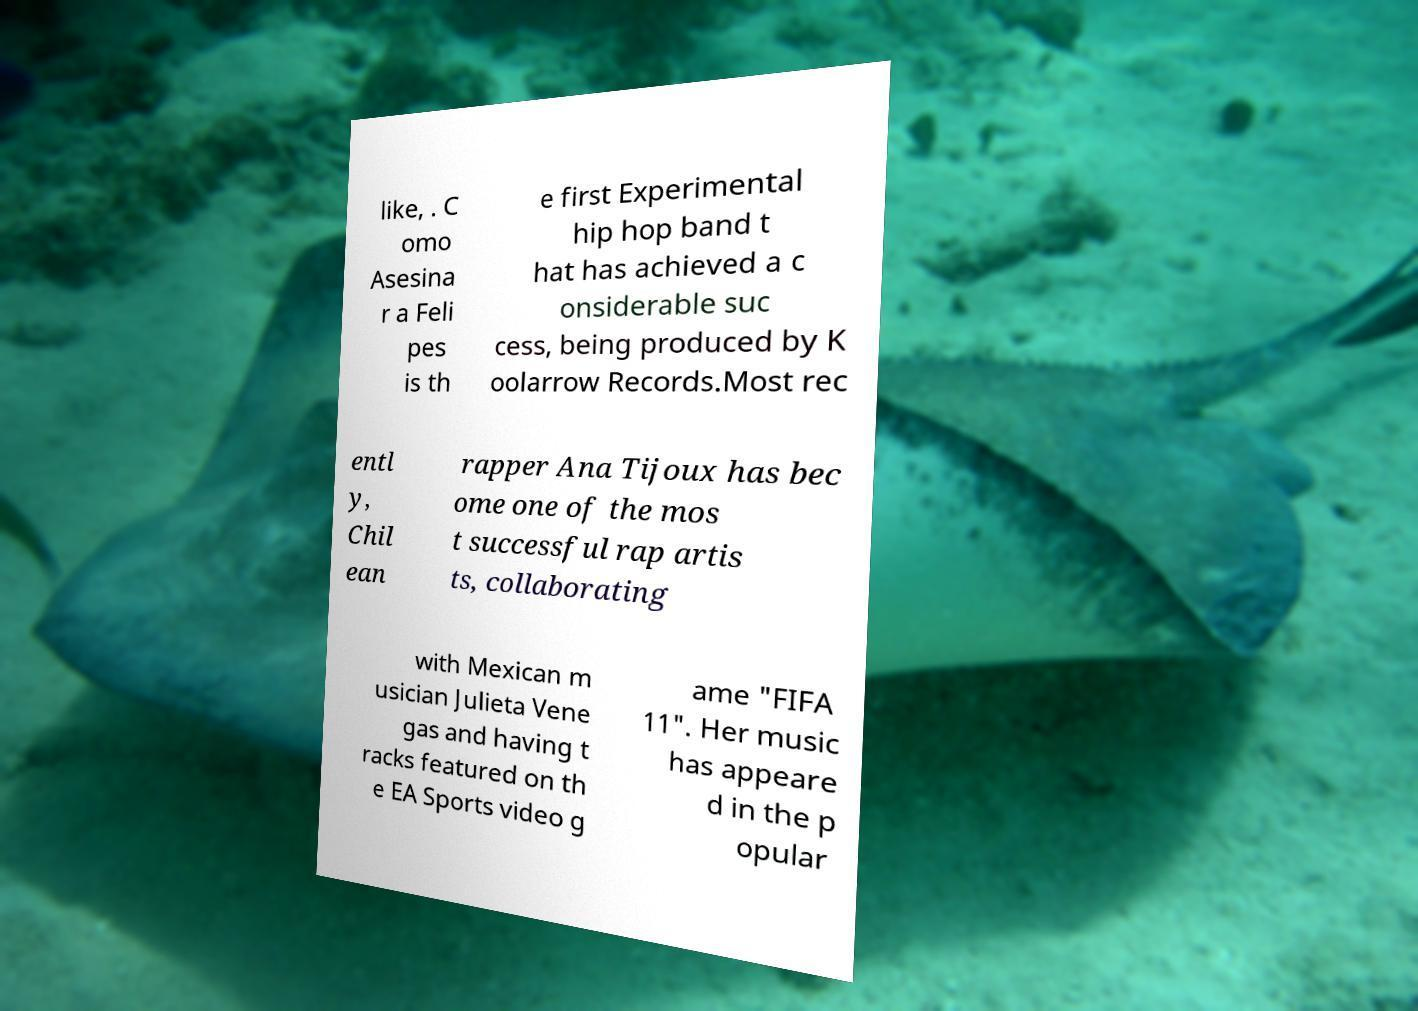I need the written content from this picture converted into text. Can you do that? like, . C omo Asesina r a Feli pes is th e first Experimental hip hop band t hat has achieved a c onsiderable suc cess, being produced by K oolarrow Records.Most rec entl y, Chil ean rapper Ana Tijoux has bec ome one of the mos t successful rap artis ts, collaborating with Mexican m usician Julieta Vene gas and having t racks featured on th e EA Sports video g ame "FIFA 11". Her music has appeare d in the p opular 